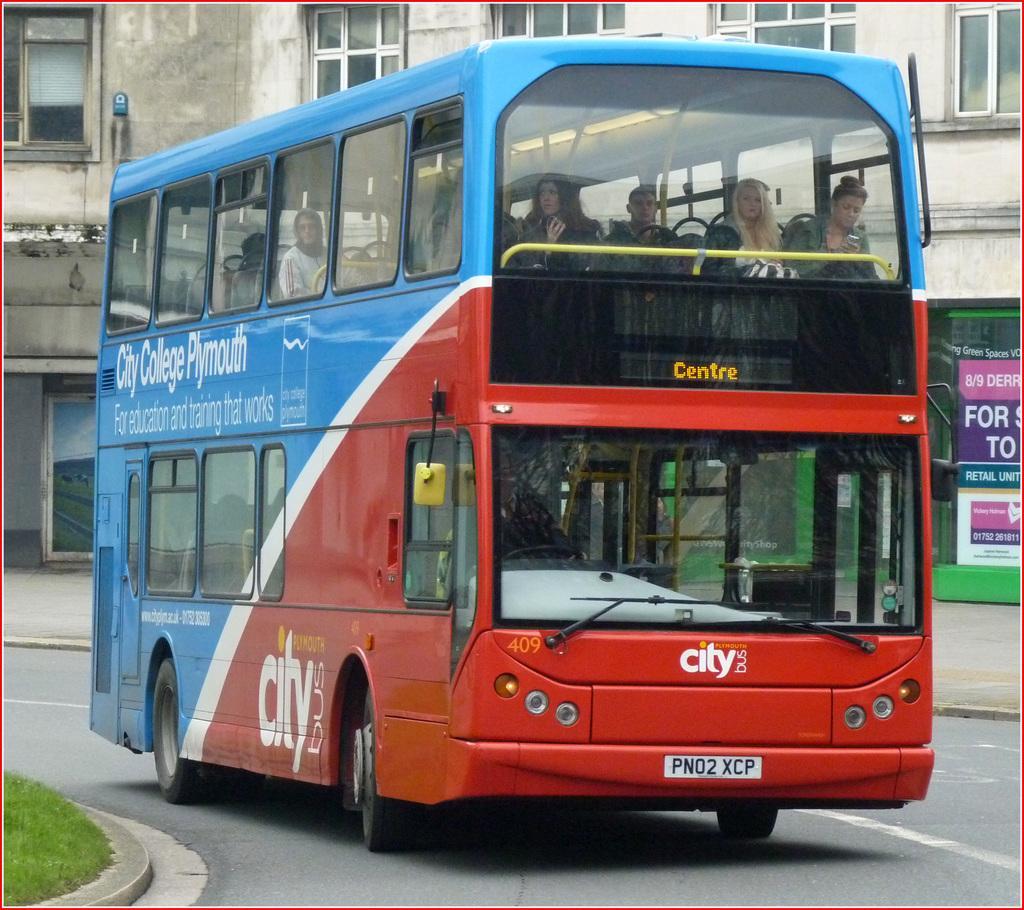In one or two sentences, can you explain what this image depicts? In this picture we can see red and blue double Decker bus moving on the road. Behind we can see the building with a glass windows. 